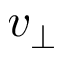Convert formula to latex. <formula><loc_0><loc_0><loc_500><loc_500>v _ { \perp }</formula> 